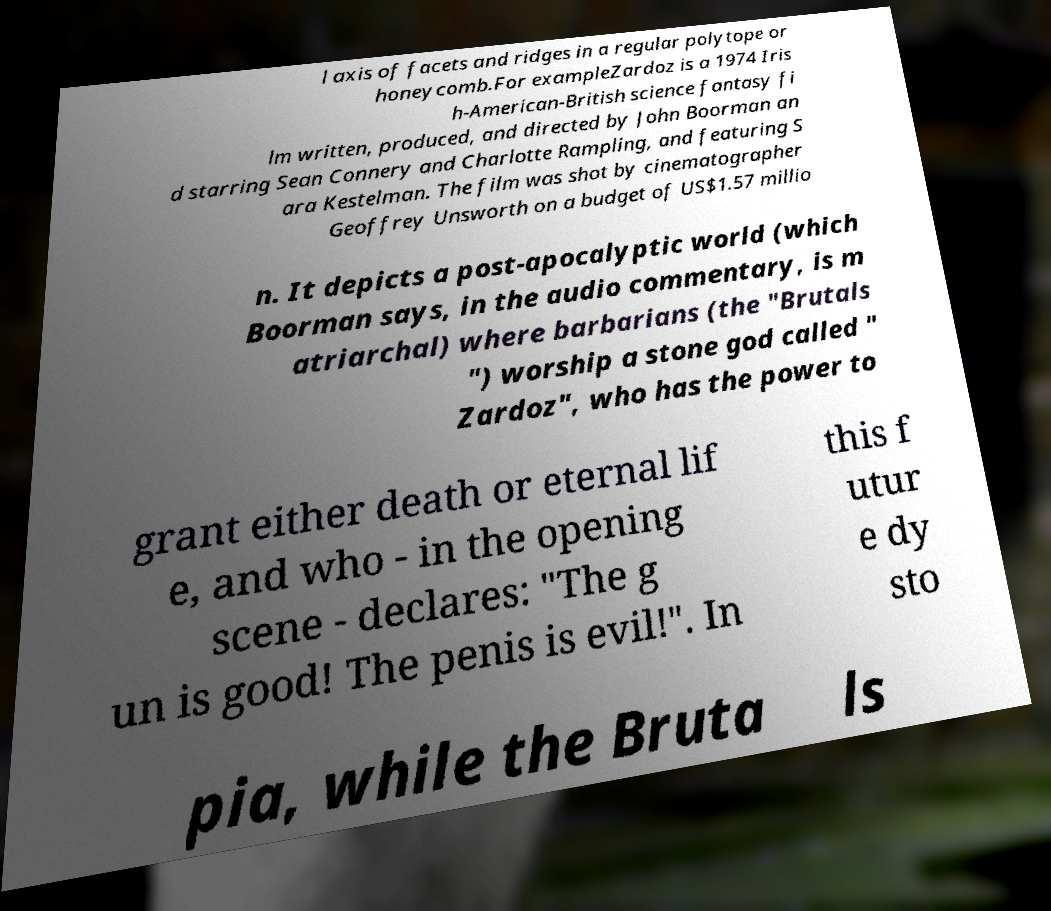Can you accurately transcribe the text from the provided image for me? l axis of facets and ridges in a regular polytope or honeycomb.For exampleZardoz is a 1974 Iris h-American-British science fantasy fi lm written, produced, and directed by John Boorman an d starring Sean Connery and Charlotte Rampling, and featuring S ara Kestelman. The film was shot by cinematographer Geoffrey Unsworth on a budget of US$1.57 millio n. It depicts a post-apocalyptic world (which Boorman says, in the audio commentary, is m atriarchal) where barbarians (the "Brutals ") worship a stone god called " Zardoz", who has the power to grant either death or eternal lif e, and who - in the opening scene - declares: "The g un is good! The penis is evil!". In this f utur e dy sto pia, while the Bruta ls 